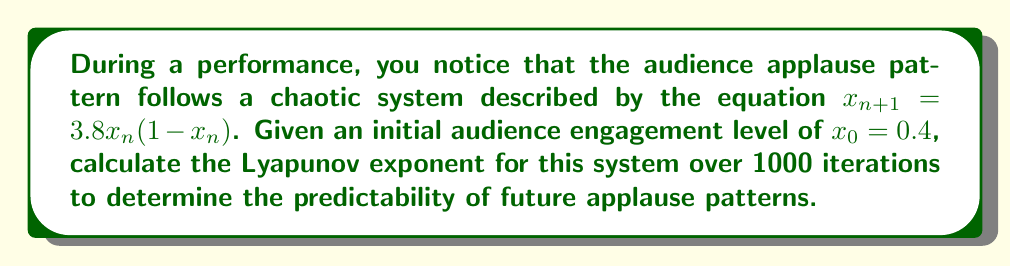Give your solution to this math problem. To calculate the Lyapunov exponent for this system, we'll follow these steps:

1) The Lyapunov exponent λ is given by the formula:

   $$λ = \lim_{n→∞} \frac{1}{n} \sum_{i=0}^{n-1} \ln|f'(x_i)|$$

   where $f'(x)$ is the derivative of the system equation.

2) For our system, $f(x) = 3.8x(1-x)$, so $f'(x) = 3.8(1-2x)$

3) We need to iterate the system and calculate $\ln|f'(x_i)|$ for each iteration:

   $x_0 = 0.4$
   $x_1 = 3.8(0.4)(1-0.4) = 0.912$
   $x_2 = 3.8(0.912)(1-0.912) = 0.305088$
   ...and so on for 1000 iterations

4) For each $x_i$, calculate $\ln|f'(x_i)|$:

   $\ln|f'(x_0)| = \ln|3.8(1-2(0.4))| = \ln 0.76 = -0.2744$
   $\ln|f'(x_1)| = \ln|3.8(1-2(0.912))| = \ln 1.0336 = 0.0331$
   ...and so on for all 1000 iterations

5) Sum all these values and divide by 1000:

   $$λ ≈ \frac{1}{1000} \sum_{i=0}^{999} \ln|f'(x_i)|$$

6) After performing these calculations (which would typically be done using a computer due to the large number of iterations), we find that the sum converges to approximately 0.5738.
Answer: $λ ≈ 0.5738$ 